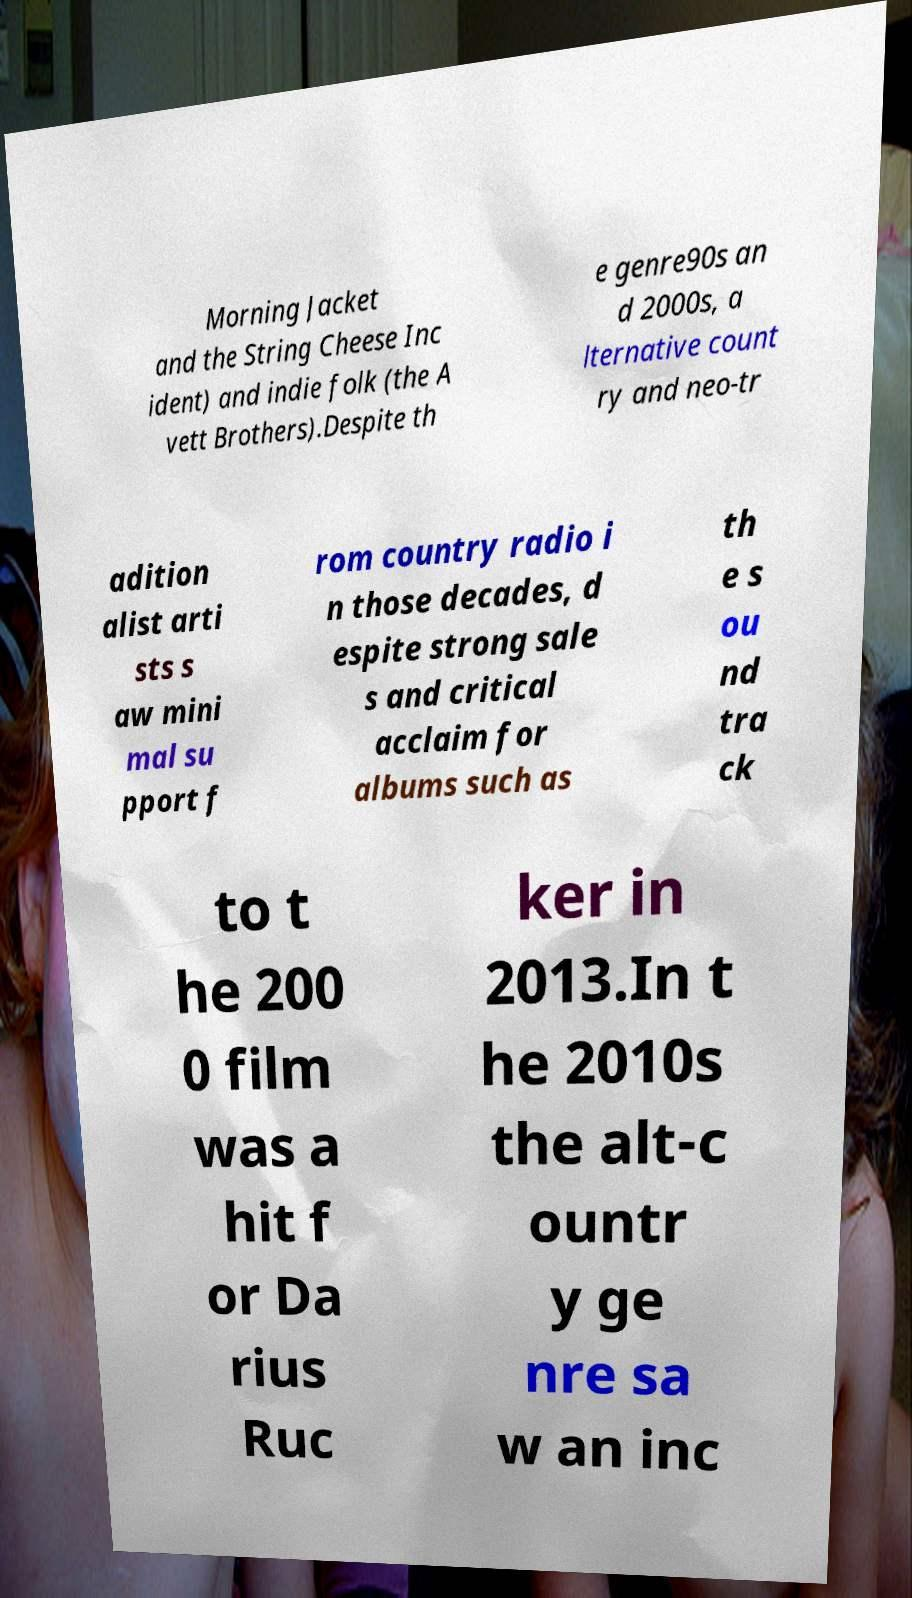Can you accurately transcribe the text from the provided image for me? Morning Jacket and the String Cheese Inc ident) and indie folk (the A vett Brothers).Despite th e genre90s an d 2000s, a lternative count ry and neo-tr adition alist arti sts s aw mini mal su pport f rom country radio i n those decades, d espite strong sale s and critical acclaim for albums such as th e s ou nd tra ck to t he 200 0 film was a hit f or Da rius Ruc ker in 2013.In t he 2010s the alt-c ountr y ge nre sa w an inc 